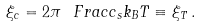Convert formula to latex. <formula><loc_0><loc_0><loc_500><loc_500>\xi _ { c } = 2 \pi \ F r a c { c _ { s } } { k _ { B } T } \equiv \xi _ { T } \, .</formula> 